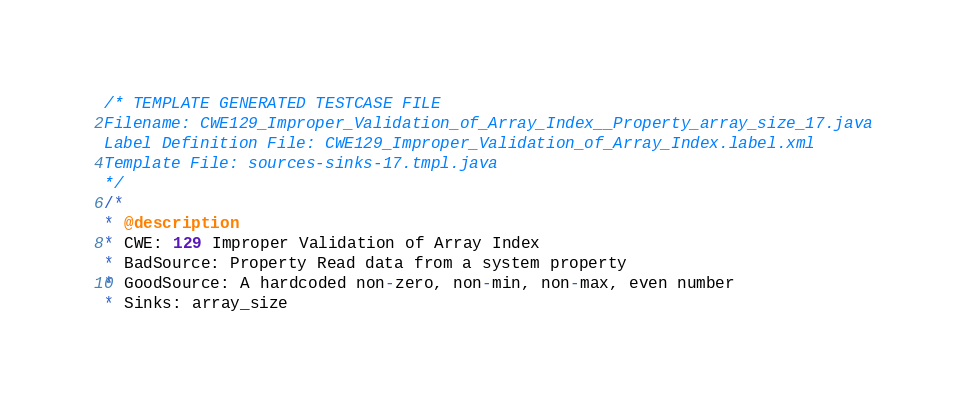<code> <loc_0><loc_0><loc_500><loc_500><_Java_>/* TEMPLATE GENERATED TESTCASE FILE
Filename: CWE129_Improper_Validation_of_Array_Index__Property_array_size_17.java
Label Definition File: CWE129_Improper_Validation_of_Array_Index.label.xml
Template File: sources-sinks-17.tmpl.java
*/
/*
* @description
* CWE: 129 Improper Validation of Array Index
* BadSource: Property Read data from a system property
* GoodSource: A hardcoded non-zero, non-min, non-max, even number
* Sinks: array_size</code> 